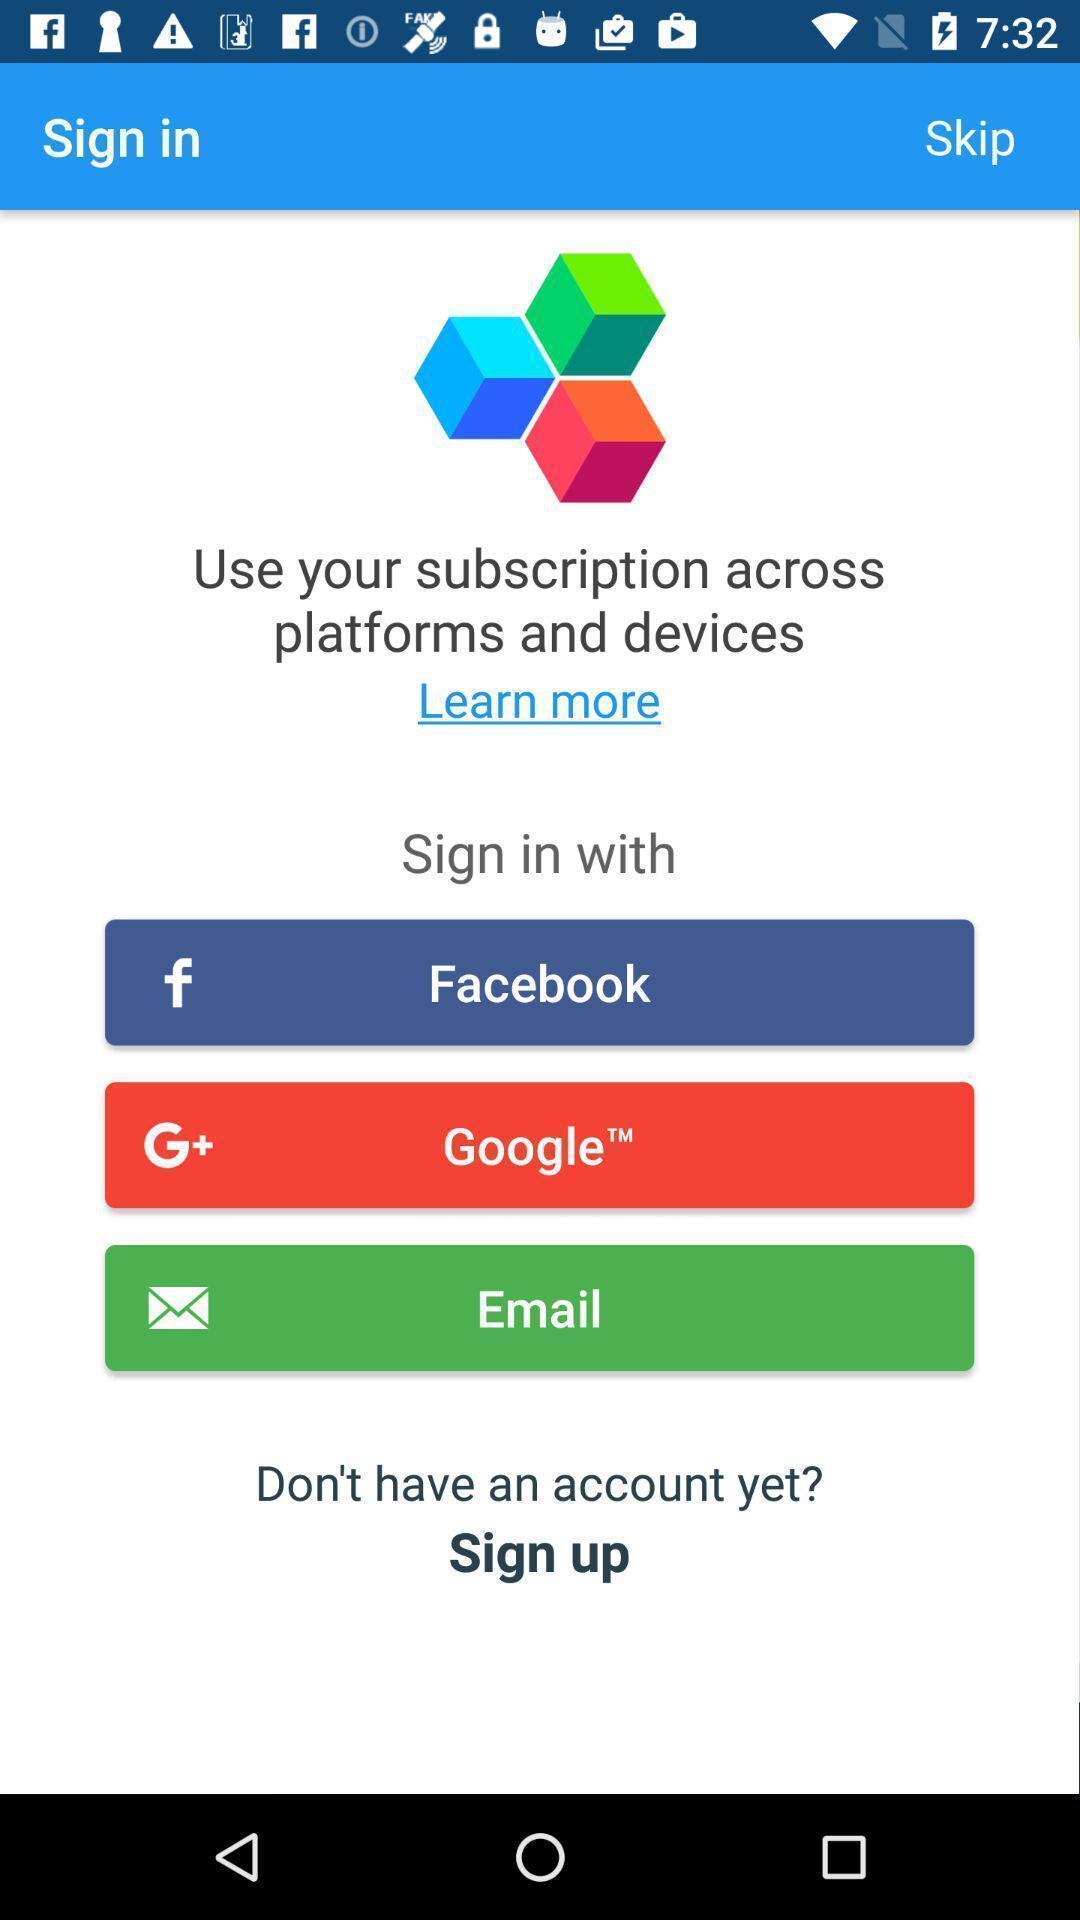Give me a narrative description of this picture. Sign in page. 